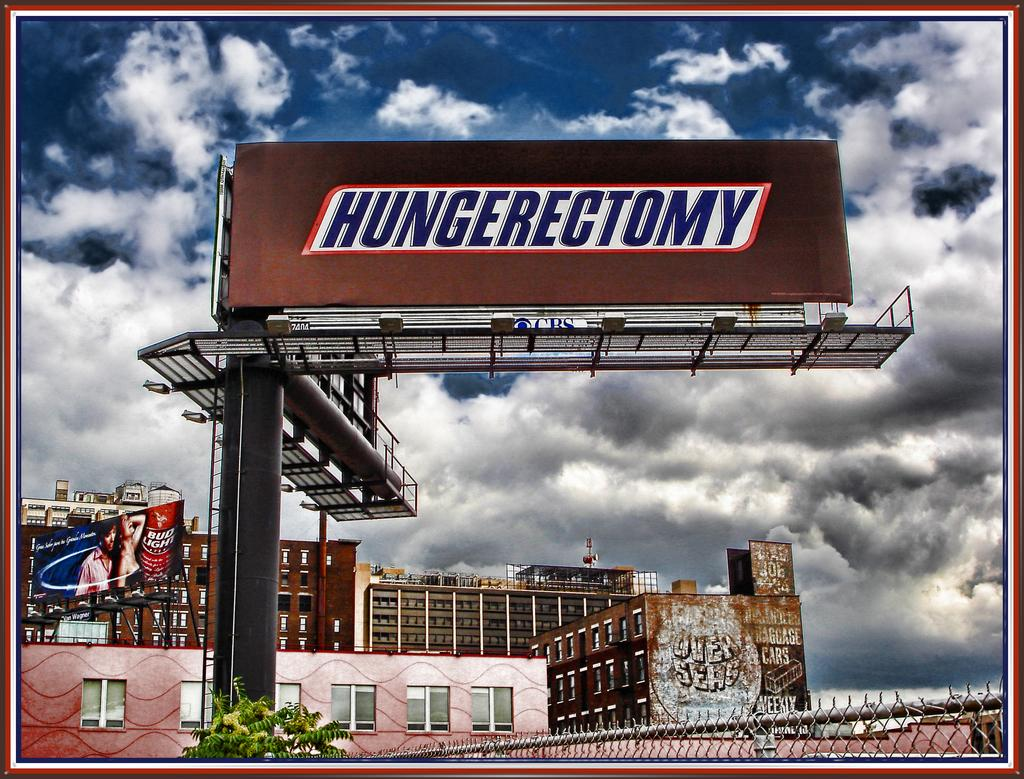<image>
Present a compact description of the photo's key features. A large billboard ad with hungerectomy written in large letters 